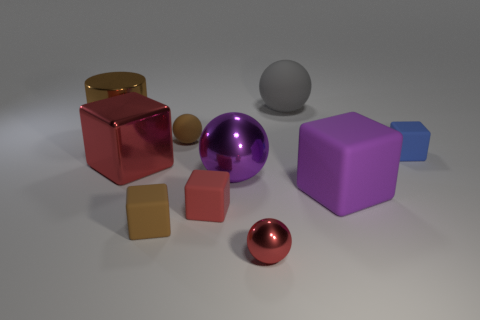There is a large brown metallic object; what shape is it?
Keep it short and to the point. Cylinder. There is a shiny object that is the same color as the big rubber block; what is its size?
Keep it short and to the point. Large. Is the small brown thing that is in front of the large purple cube made of the same material as the big brown thing?
Give a very brief answer. No. Is there a big metallic sphere that has the same color as the large rubber block?
Your answer should be compact. Yes. Is the shape of the red metal object behind the large purple sphere the same as the metal object behind the blue thing?
Give a very brief answer. No. Is there a large green object that has the same material as the tiny red sphere?
Keep it short and to the point. No. What number of blue objects are either small blocks or big rubber spheres?
Offer a terse response. 1. There is a thing that is both behind the red shiny block and to the left of the brown rubber block; what size is it?
Your answer should be compact. Large. Is the number of cubes left of the small metallic ball greater than the number of gray objects?
Give a very brief answer. Yes. How many balls are tiny red metallic things or big gray matte things?
Offer a terse response. 2. 